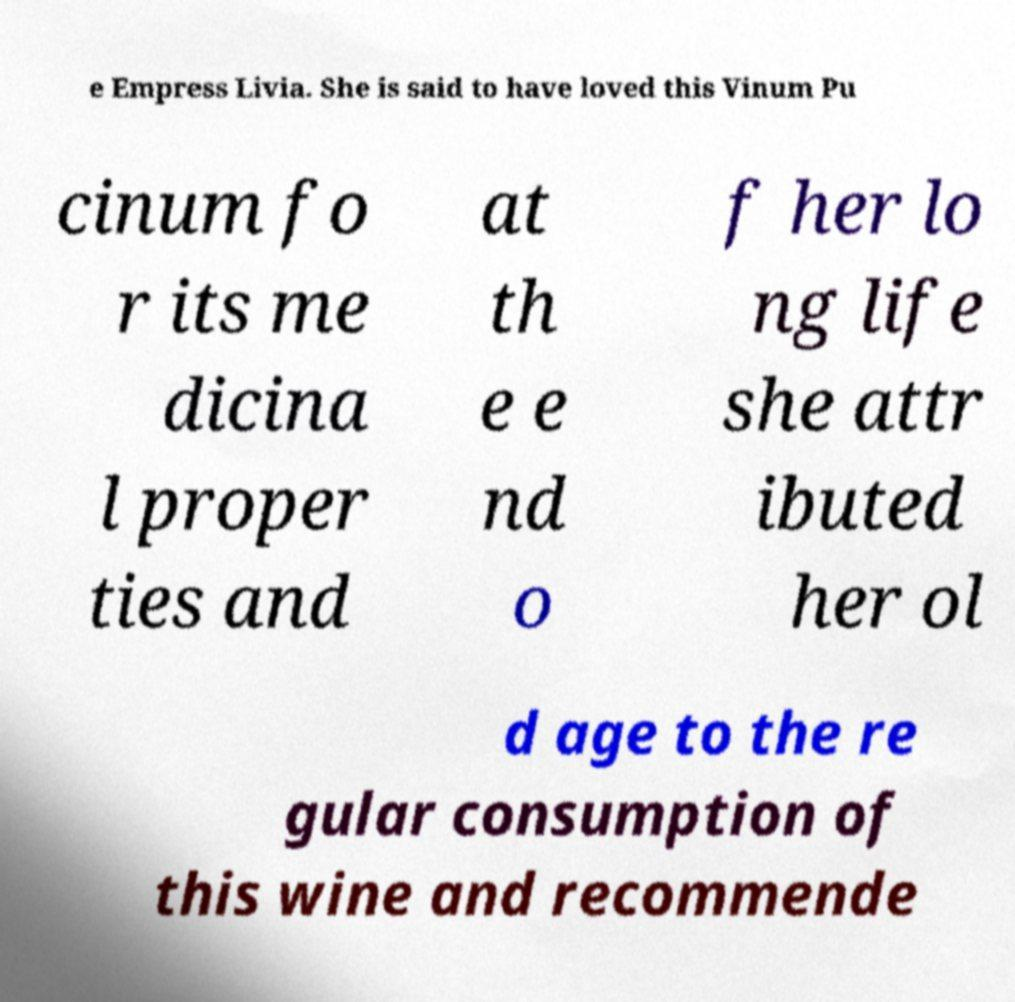Please identify and transcribe the text found in this image. e Empress Livia. She is said to have loved this Vinum Pu cinum fo r its me dicina l proper ties and at th e e nd o f her lo ng life she attr ibuted her ol d age to the re gular consumption of this wine and recommende 